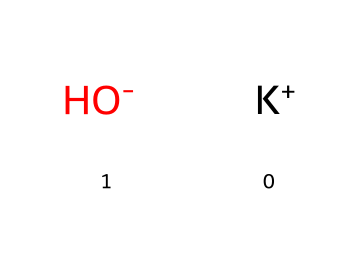What ions are present in potassium hydroxide? The chemical structure shows potassium as K+ and hydroxide as OH-. Therefore, the ions present are the potassium ion and the hydroxide ion.
Answer: potassium and hydroxide How many different elements are in potassium hydroxide? The SMILES representation indicates the presence of potassium (K) and oxygen (O) along with hydrogen (H) in the hydroxide ion. Hence, there are three different elements: potassium, oxygen, and hydrogen.
Answer: three What is the charge of the potassium ion in this compound? In the SMILES representation, K+ indicates that the potassium ion has a positive charge. Therefore, the charge is positive one.
Answer: positive one What type of substance is potassium hydroxide classified as? Potassium hydroxide's structure features a metal ion (K+) and a hydroxide ion (OH-), which are characteristic of bases. Thus, it is classified as a base.
Answer: base Why is potassium hydroxide used in ski lift lubricants? Potassium hydroxide's properties include being a strong base, making it effective at lowering friction and providing lubrication under cold conditions, necessary for ski lifts.
Answer: effective lubrication 